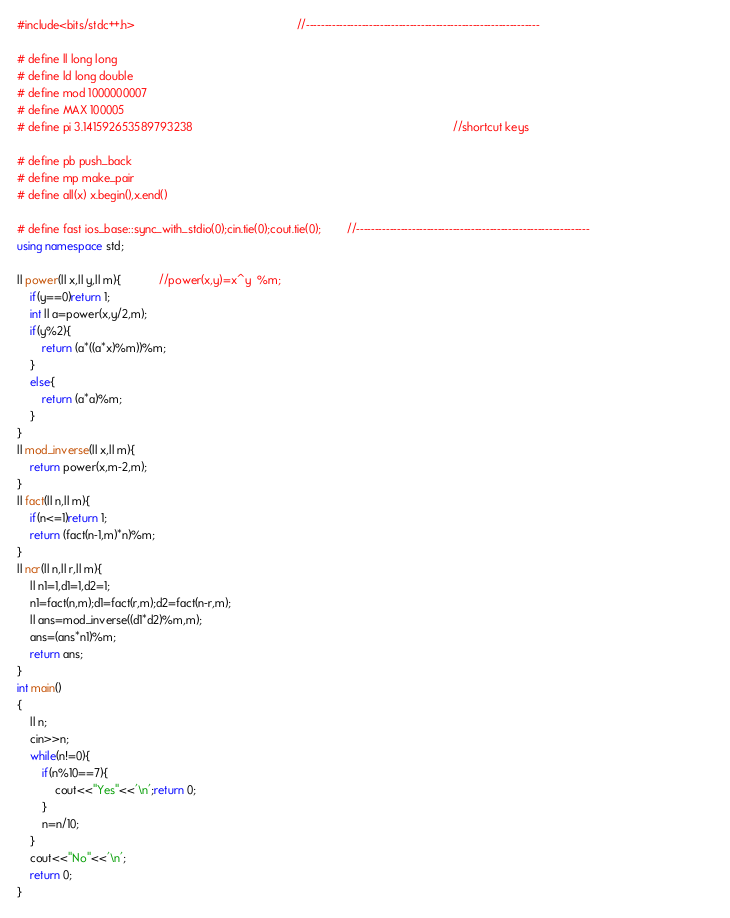Convert code to text. <code><loc_0><loc_0><loc_500><loc_500><_C++_>#include<bits/stdc++.h>                                                   //---------------------------------------------------------------
                                                                    
# define ll long long   
# define ld long double                                               
# define mod 1000000007                                                   
# define MAX 100005
# define pi 3.141592653589793238                                                                                  //shortcut keys
                                                                                
# define pb push_back                                                                     
# define mp make_pair 
# define all(x) x.begin(),x.end()                                                      
                                                                  
# define fast ios_base::sync_with_stdio(0);cin.tie(0);cout.tie(0);        //---------------------------------------------------------------                                       
using namespace std;

ll power(ll x,ll y,ll m){            //power(x,y)=x^y  %m;
	if(y==0)return 1;
	int ll a=power(x,y/2,m);
	if(y%2){
		return (a*((a*x)%m))%m;
	}
	else{
		return (a*a)%m;
	}
}
ll mod_inverse(ll x,ll m){
	return power(x,m-2,m);
}
ll fact(ll n,ll m){
	if(n<=1)return 1;
	return (fact(n-1,m)*n)%m;
}
ll ncr(ll n,ll r,ll m){
	ll n1=1,d1=1,d2=1;
	n1=fact(n,m);d1=fact(r,m);d2=fact(n-r,m);
	ll ans=mod_inverse((d1*d2)%m,m);
	ans=(ans*n1)%m;
	return ans;
}
int main()
{
	ll n;
	cin>>n;
	while(n!=0){
		if(n%10==7){
			cout<<"Yes"<<'\n';return 0;
		}
		n=n/10;
	}
	cout<<"No"<<'\n';
	return 0;
}


</code> 